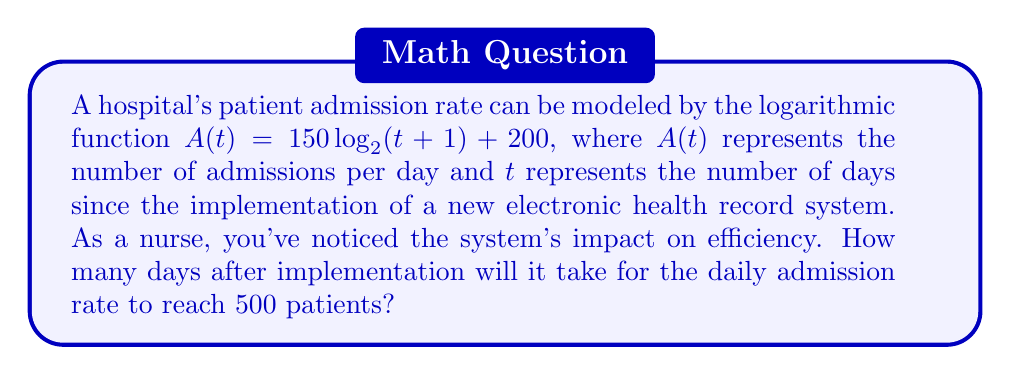What is the answer to this math problem? To solve this problem, we need to follow these steps:

1) We're given the function $A(t) = 150 \log_2(t+1) + 200$, and we want to find $t$ when $A(t) = 500$.

2) Let's substitute these values into the equation:
   
   $500 = 150 \log_2(t+1) + 200$

3) Subtract 200 from both sides:
   
   $300 = 150 \log_2(t+1)$

4) Divide both sides by 150:
   
   $2 = \log_2(t+1)$

5) To solve for $t$, we need to apply the inverse function (exponential) to both sides:
   
   $2^2 = t+1$

6) Simplify:
   
   $4 = t+1$

7) Subtract 1 from both sides:
   
   $3 = t$

Therefore, it will take 3 days after implementation for the daily admission rate to reach 500 patients.
Answer: 3 days 